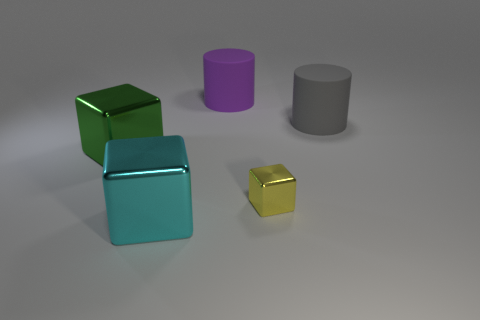Add 1 large metallic cubes. How many objects exist? 6 Subtract all blocks. How many objects are left? 2 Subtract all purple things. Subtract all gray matte cylinders. How many objects are left? 3 Add 5 small yellow shiny blocks. How many small yellow shiny blocks are left? 6 Add 3 large cyan blocks. How many large cyan blocks exist? 4 Subtract 0 gray balls. How many objects are left? 5 